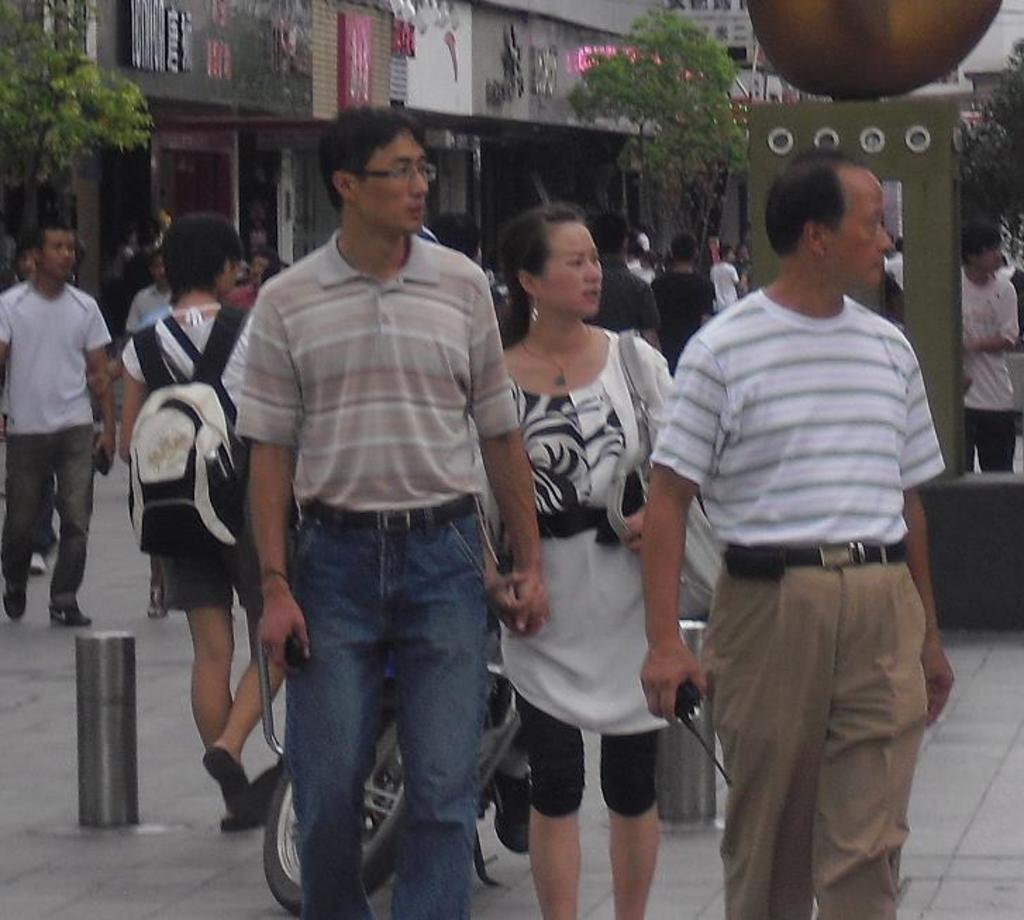What are the people in the image doing? The people in the image are walking on the streets. What can be seen on the street besides the people? There is a bike parked on the street. What is visible in the background of the image? There are trees and buildings in the background of the image. What type of suit is the person in the image wearing? There is no person wearing a suit in the image. Can you see any spacecraft in the image? There are no spacecraft present in the image. 